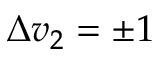Convert formula to latex. <formula><loc_0><loc_0><loc_500><loc_500>\Delta v _ { 2 } = \pm 1</formula> 